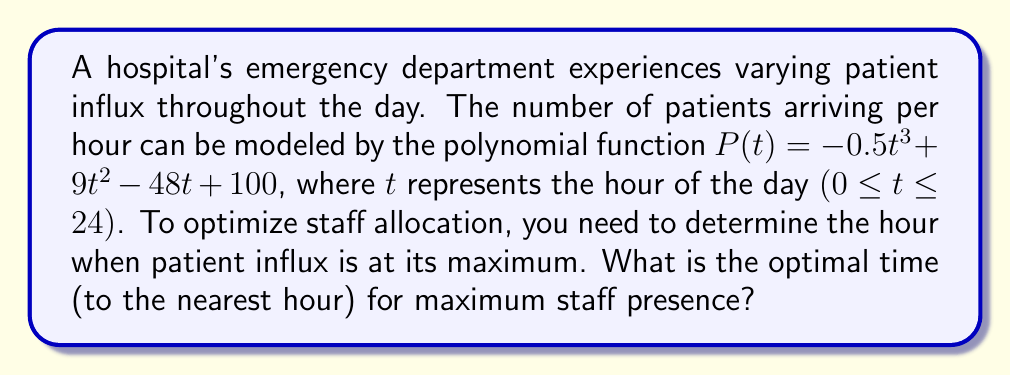Help me with this question. To find the maximum patient influx, we need to determine the peak of the polynomial function $P(t)$. This occurs where the derivative of $P(t)$ equals zero.

1) First, let's find the derivative of $P(t)$:
   $P'(t) = -1.5t^2 + 18t - 48$

2) Set $P'(t) = 0$ and solve for $t$:
   $-1.5t^2 + 18t - 48 = 0$

3) This is a quadratic equation. We can solve it using the quadratic formula:
   $t = \frac{-b \pm \sqrt{b^2 - 4ac}}{2a}$

   Where $a = -1.5$, $b = 18$, and $c = -48$

4) Substituting these values:
   $t = \frac{-18 \pm \sqrt{18^2 - 4(-1.5)(-48)}}{2(-1.5)}$
   $= \frac{-18 \pm \sqrt{324 - 288}}{-3}$
   $= \frac{-18 \pm \sqrt{36}}{-3}$
   $= \frac{-18 \pm 6}{-3}$

5) This gives us two solutions:
   $t_1 = \frac{-18 + 6}{-3} = 4$
   $t_2 = \frac{-18 - 6}{-3} = 8$

6) To determine which of these is the maximum (rather than the minimum), we can check the second derivative:
   $P''(t) = -3t + 18$

   At $t = 4$: $P''(4) = -3(4) + 18 = 6 > 0$
   At $t = 8$: $P''(8) = -3(8) + 18 = -6 < 0$

   Since $P''(8) < 0$, the maximum occurs at $t = 8$.

Therefore, the patient influx is at its maximum at the 8th hour of the day, or 8:00 AM.
Answer: 8:00 AM 